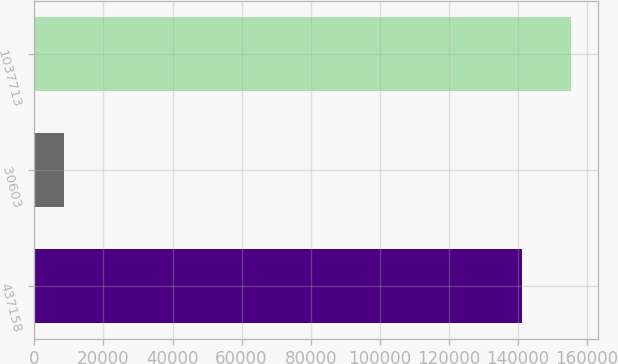Convert chart. <chart><loc_0><loc_0><loc_500><loc_500><bar_chart><fcel>437158<fcel>30603<fcel>1037713<nl><fcel>141284<fcel>8445<fcel>155412<nl></chart> 